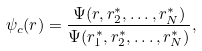<formula> <loc_0><loc_0><loc_500><loc_500>\psi _ { c } ( r ) = \frac { \Psi ( r , r ^ { * } _ { 2 } , \dots , r ^ { * } _ { N } ) } { \Psi ( r ^ { * } _ { 1 } , r ^ { * } _ { 2 } , \dots , r ^ { * } _ { N } ) } ,</formula> 